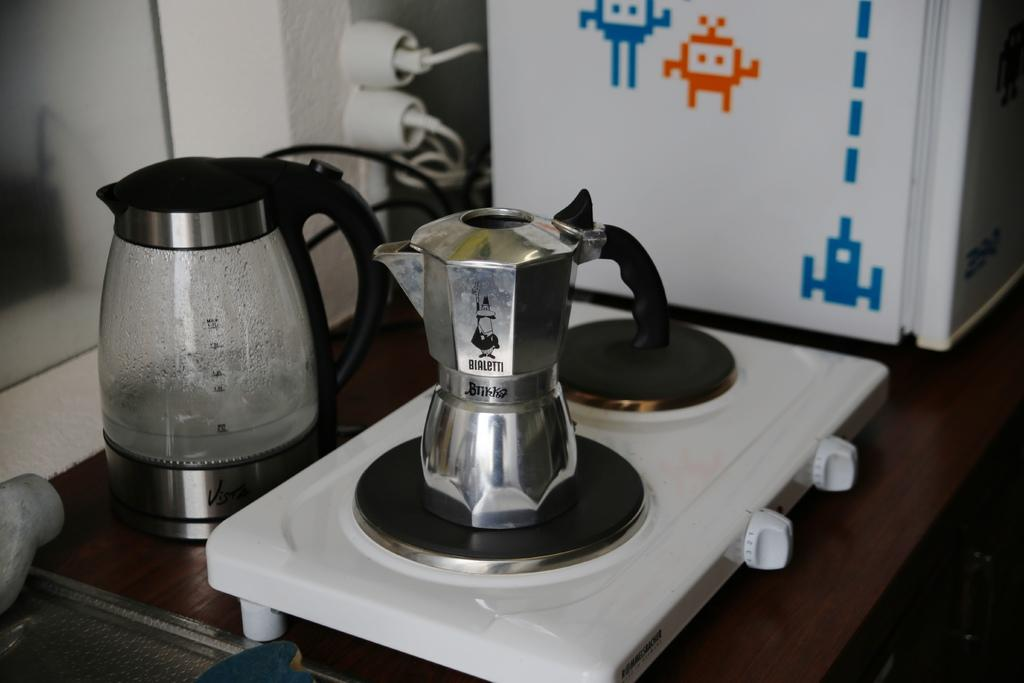<image>
Share a concise interpretation of the image provided. A silver coffee pot with the words Bialetti and Btikka on it. 